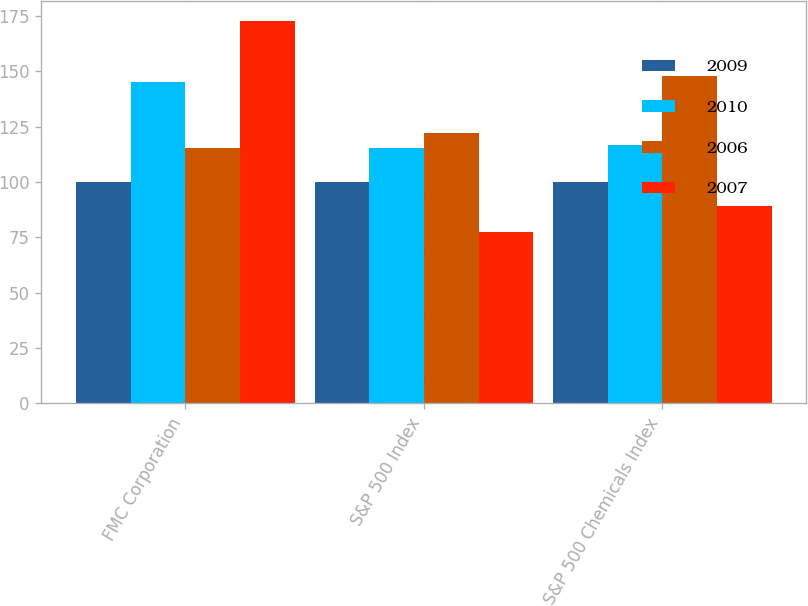Convert chart. <chart><loc_0><loc_0><loc_500><loc_500><stacked_bar_chart><ecel><fcel>FMC Corporation<fcel>S&P 500 Index<fcel>S&P 500 Chemicals Index<nl><fcel>2009<fcel>100<fcel>100<fcel>100<nl><fcel>2010<fcel>145.33<fcel>115.61<fcel>116.58<nl><fcel>2006<fcel>115.61<fcel>121.95<fcel>147.74<nl><fcel>2007<fcel>172.93<fcel>77.41<fcel>89.37<nl></chart> 